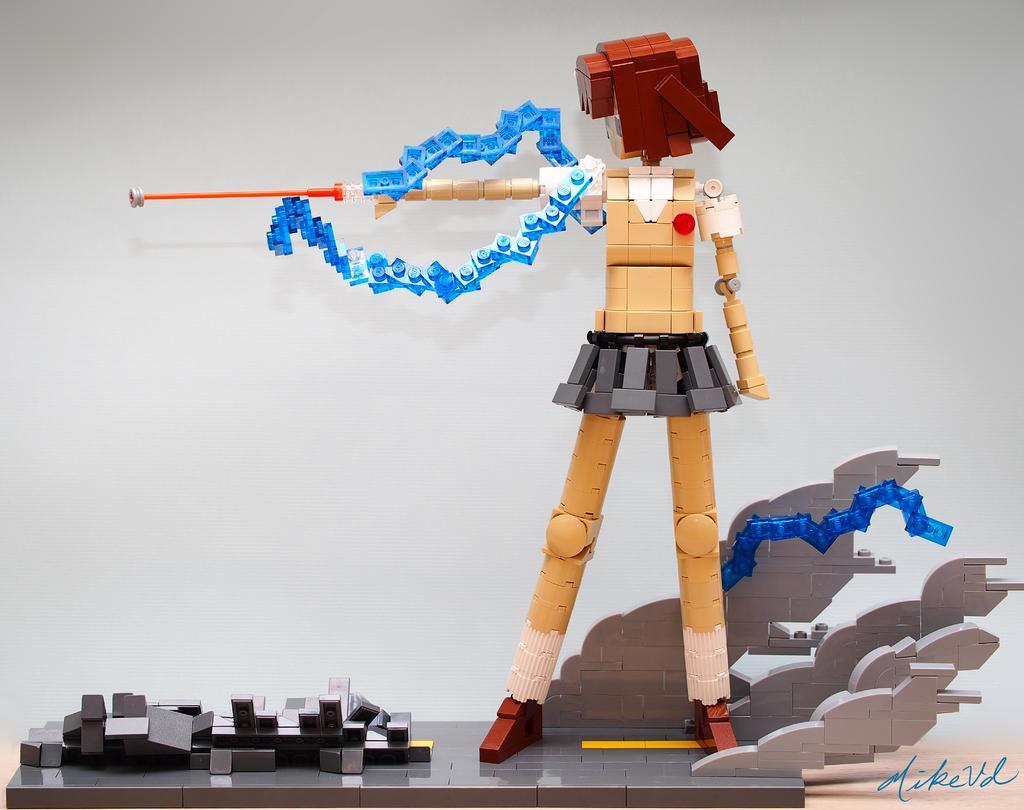In one or two sentences, can you explain what this image depicts? In this picture we can see a Lego. We can see a text in the bottom right. There is a white background. 